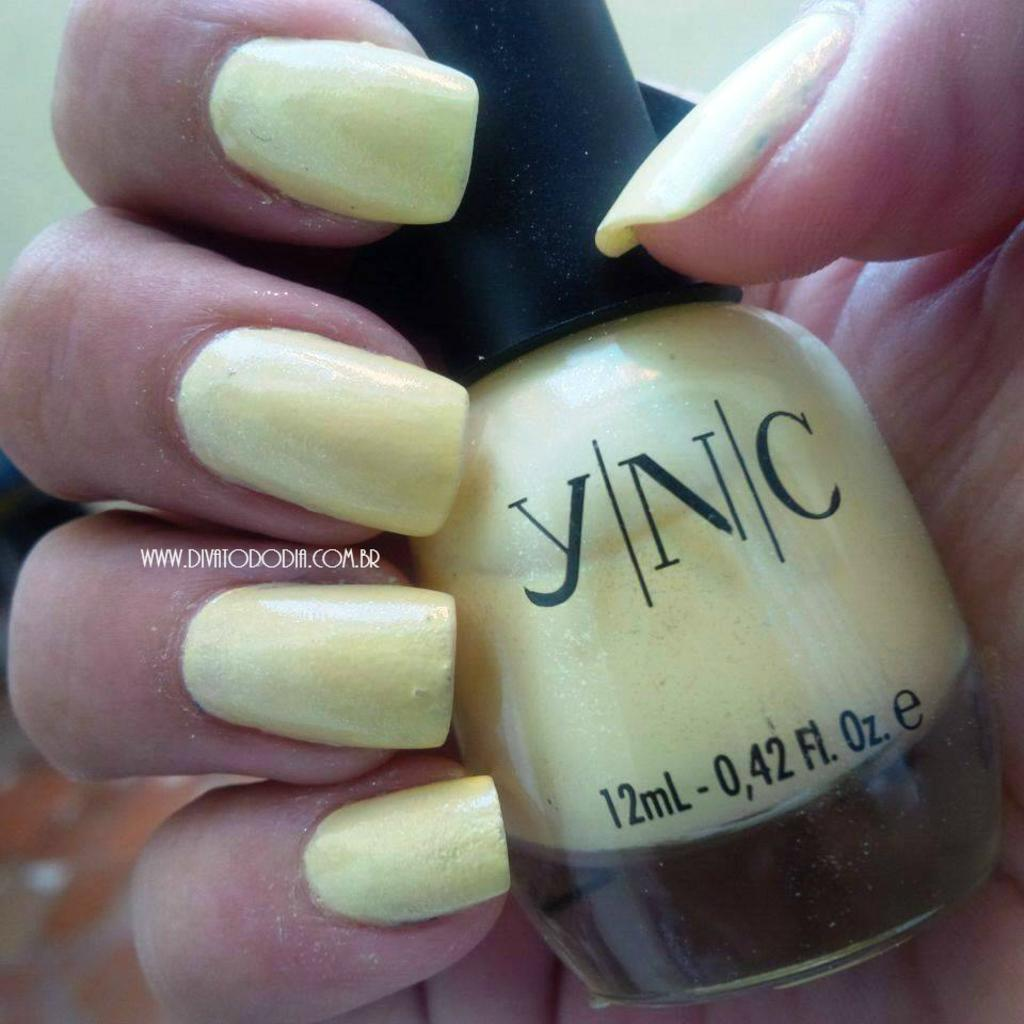What object is being held by a person in the image? There is a nail polish in the person's hand in the image. What is the purpose of the object being held? The nail polish is used for painting nails. Is there any text or labeling on the nail polish? Yes, there is text on the nail polish. What type of tax is being discussed in the image? There is no discussion of tax in the image; it features a person holding a nail polish. Can you tell me how many skateboards are visible in the image? There are no skateboards present in the image. 